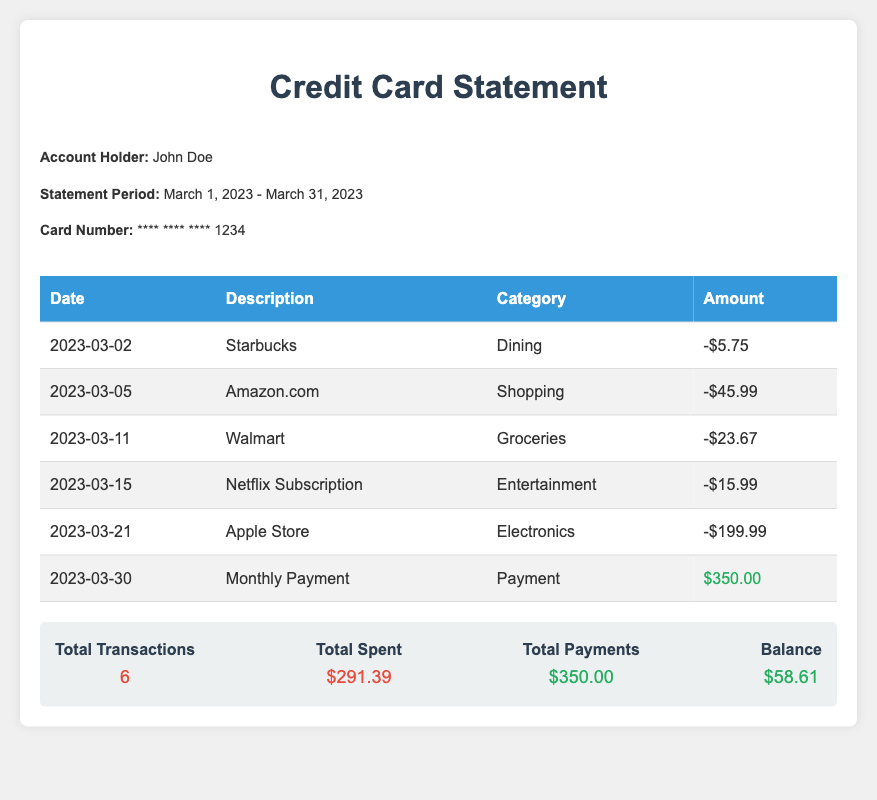what is the account holder's name? The document states that the account holder is John Doe.
Answer: John Doe what is the statement period for the document? The statement period mentioned is from March 1, 2023 to March 31, 2023.
Answer: March 1, 2023 - March 31, 2023 how many total transactions were made? The document lists a total of 6 transactions.
Answer: 6 what was the amount spent at the Apple Store? The transaction for the Apple Store is noted as a spending of $199.99.
Answer: $199.99 what is the balance at the end of the statement period? The document shows a balance of $58.61 after all transactions.
Answer: $58.61 what was the total amount spent during March 2023? The total spent is calculated from all transactions listed and is stated as $291.39.
Answer: $291.39 when was the monthly payment made? The monthly payment was made on March 30, 2023.
Answer: March 30, 2023 what type of transaction is the Netflix Subscription? The categorization for the Netflix Subscription is marked as Entertainment.
Answer: Entertainment what was the total amount of payments made? The total payments recorded in the document amount to $350.00.
Answer: $350.00 